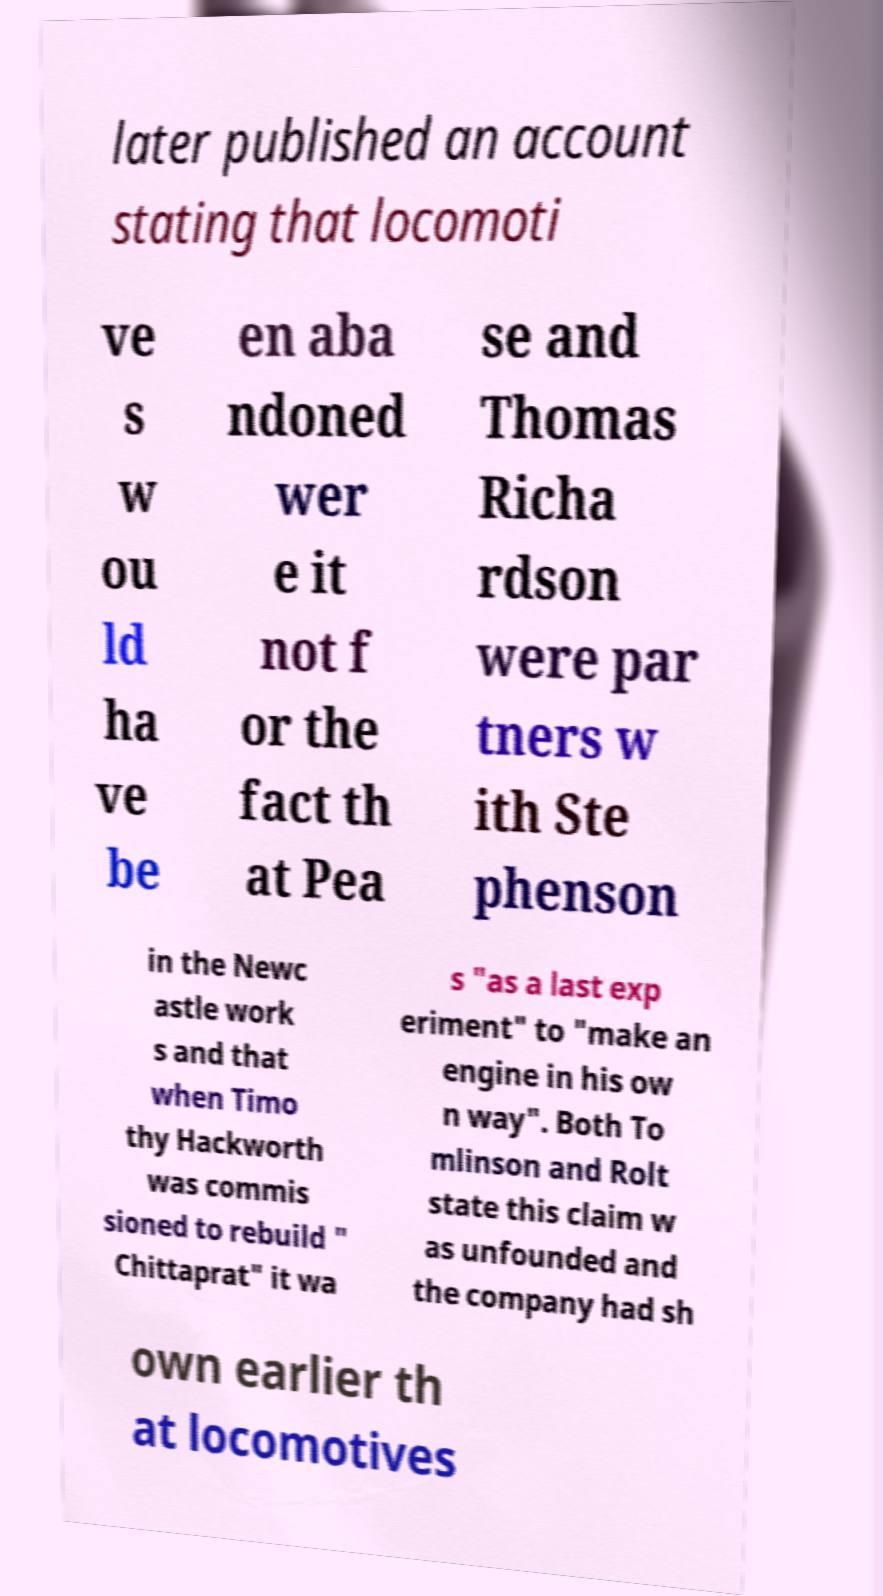Can you read and provide the text displayed in the image?This photo seems to have some interesting text. Can you extract and type it out for me? later published an account stating that locomoti ve s w ou ld ha ve be en aba ndoned wer e it not f or the fact th at Pea se and Thomas Richa rdson were par tners w ith Ste phenson in the Newc astle work s and that when Timo thy Hackworth was commis sioned to rebuild " Chittaprat" it wa s "as a last exp eriment" to "make an engine in his ow n way". Both To mlinson and Rolt state this claim w as unfounded and the company had sh own earlier th at locomotives 